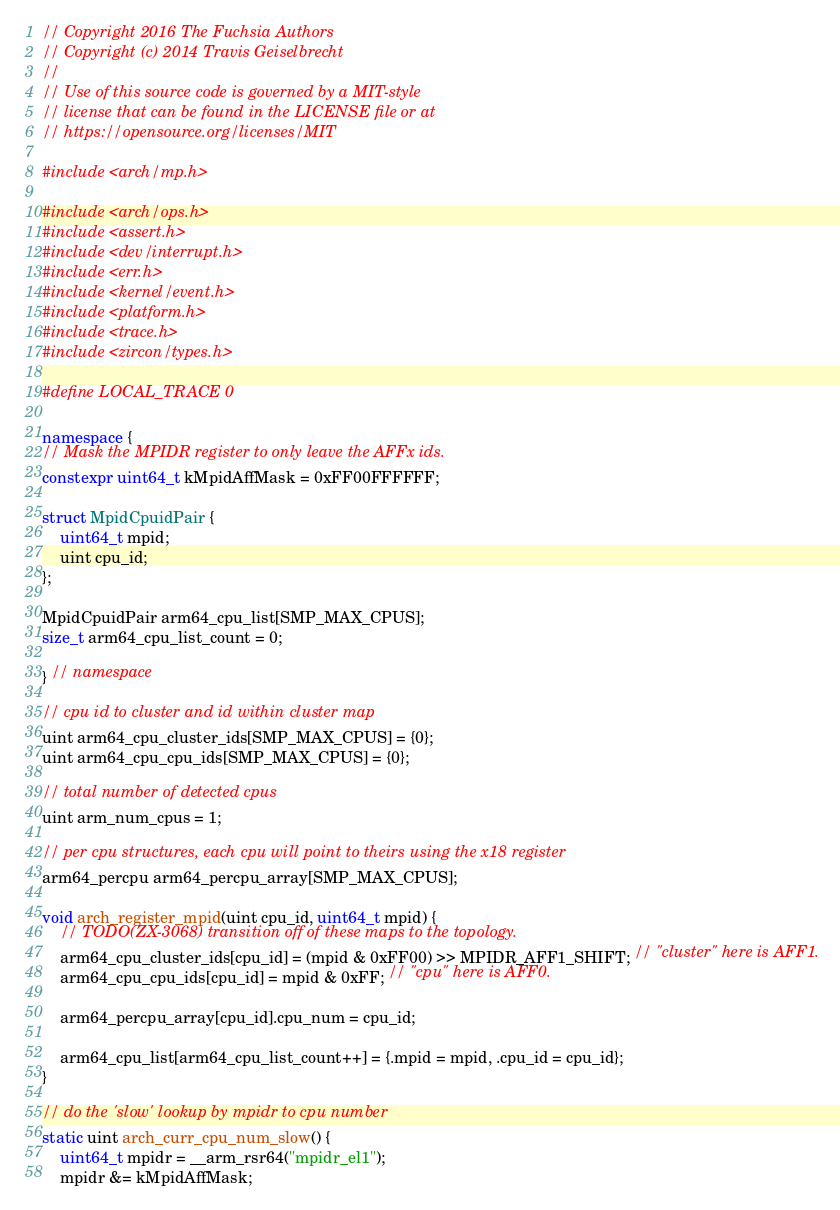Convert code to text. <code><loc_0><loc_0><loc_500><loc_500><_C++_>// Copyright 2016 The Fuchsia Authors
// Copyright (c) 2014 Travis Geiselbrecht
//
// Use of this source code is governed by a MIT-style
// license that can be found in the LICENSE file or at
// https://opensource.org/licenses/MIT

#include <arch/mp.h>

#include <arch/ops.h>
#include <assert.h>
#include <dev/interrupt.h>
#include <err.h>
#include <kernel/event.h>
#include <platform.h>
#include <trace.h>
#include <zircon/types.h>

#define LOCAL_TRACE 0

namespace {
// Mask the MPIDR register to only leave the AFFx ids.
constexpr uint64_t kMpidAffMask = 0xFF00FFFFFF;

struct MpidCpuidPair {
    uint64_t mpid;
    uint cpu_id;
};

MpidCpuidPair arm64_cpu_list[SMP_MAX_CPUS];
size_t arm64_cpu_list_count = 0;

} // namespace

// cpu id to cluster and id within cluster map
uint arm64_cpu_cluster_ids[SMP_MAX_CPUS] = {0};
uint arm64_cpu_cpu_ids[SMP_MAX_CPUS] = {0};

// total number of detected cpus
uint arm_num_cpus = 1;

// per cpu structures, each cpu will point to theirs using the x18 register
arm64_percpu arm64_percpu_array[SMP_MAX_CPUS];

void arch_register_mpid(uint cpu_id, uint64_t mpid) {
    // TODO(ZX-3068) transition off of these maps to the topology.
    arm64_cpu_cluster_ids[cpu_id] = (mpid & 0xFF00) >> MPIDR_AFF1_SHIFT; // "cluster" here is AFF1.
    arm64_cpu_cpu_ids[cpu_id] = mpid & 0xFF; // "cpu" here is AFF0.

    arm64_percpu_array[cpu_id].cpu_num = cpu_id;

    arm64_cpu_list[arm64_cpu_list_count++] = {.mpid = mpid, .cpu_id = cpu_id};
}

// do the 'slow' lookup by mpidr to cpu number
static uint arch_curr_cpu_num_slow() {
    uint64_t mpidr = __arm_rsr64("mpidr_el1");
    mpidr &= kMpidAffMask;
</code> 